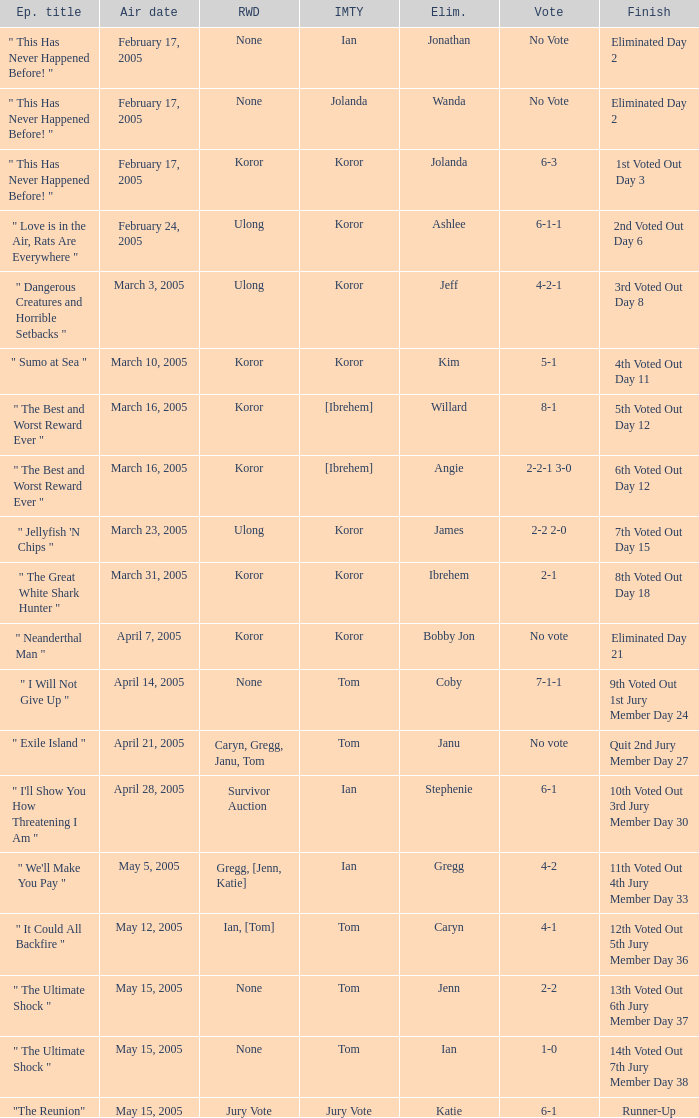Who received the reward on the episode where the finish was "3rd voted out day 8"? Ulong. 